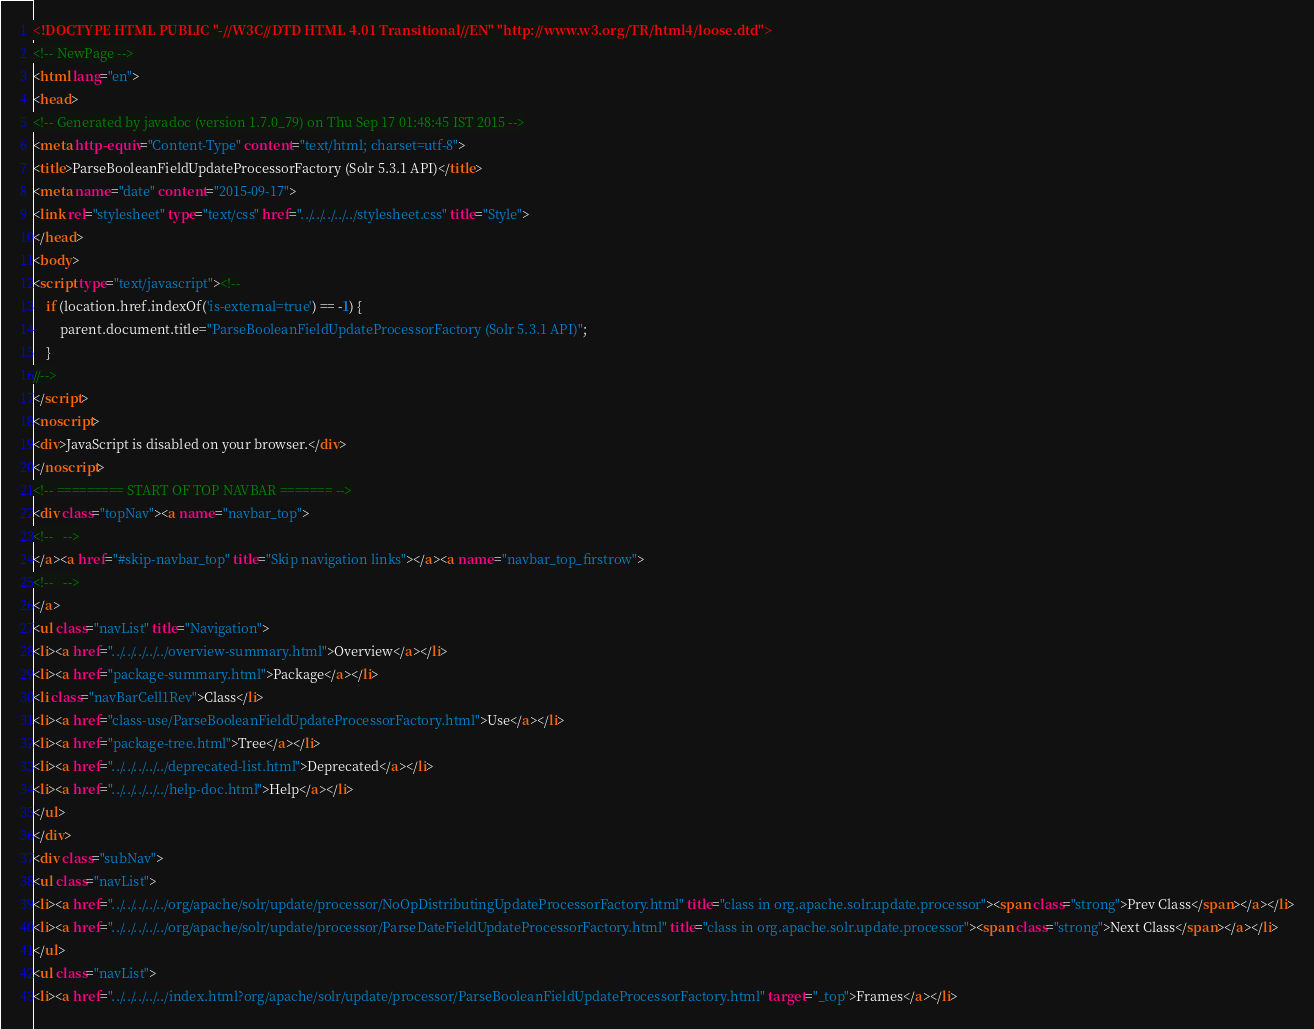Convert code to text. <code><loc_0><loc_0><loc_500><loc_500><_HTML_><!DOCTYPE HTML PUBLIC "-//W3C//DTD HTML 4.01 Transitional//EN" "http://www.w3.org/TR/html4/loose.dtd">
<!-- NewPage -->
<html lang="en">
<head>
<!-- Generated by javadoc (version 1.7.0_79) on Thu Sep 17 01:48:45 IST 2015 -->
<meta http-equiv="Content-Type" content="text/html; charset=utf-8">
<title>ParseBooleanFieldUpdateProcessorFactory (Solr 5.3.1 API)</title>
<meta name="date" content="2015-09-17">
<link rel="stylesheet" type="text/css" href="../../../../../stylesheet.css" title="Style">
</head>
<body>
<script type="text/javascript"><!--
    if (location.href.indexOf('is-external=true') == -1) {
        parent.document.title="ParseBooleanFieldUpdateProcessorFactory (Solr 5.3.1 API)";
    }
//-->
</script>
<noscript>
<div>JavaScript is disabled on your browser.</div>
</noscript>
<!-- ========= START OF TOP NAVBAR ======= -->
<div class="topNav"><a name="navbar_top">
<!--   -->
</a><a href="#skip-navbar_top" title="Skip navigation links"></a><a name="navbar_top_firstrow">
<!--   -->
</a>
<ul class="navList" title="Navigation">
<li><a href="../../../../../overview-summary.html">Overview</a></li>
<li><a href="package-summary.html">Package</a></li>
<li class="navBarCell1Rev">Class</li>
<li><a href="class-use/ParseBooleanFieldUpdateProcessorFactory.html">Use</a></li>
<li><a href="package-tree.html">Tree</a></li>
<li><a href="../../../../../deprecated-list.html">Deprecated</a></li>
<li><a href="../../../../../help-doc.html">Help</a></li>
</ul>
</div>
<div class="subNav">
<ul class="navList">
<li><a href="../../../../../org/apache/solr/update/processor/NoOpDistributingUpdateProcessorFactory.html" title="class in org.apache.solr.update.processor"><span class="strong">Prev Class</span></a></li>
<li><a href="../../../../../org/apache/solr/update/processor/ParseDateFieldUpdateProcessorFactory.html" title="class in org.apache.solr.update.processor"><span class="strong">Next Class</span></a></li>
</ul>
<ul class="navList">
<li><a href="../../../../../index.html?org/apache/solr/update/processor/ParseBooleanFieldUpdateProcessorFactory.html" target="_top">Frames</a></li></code> 